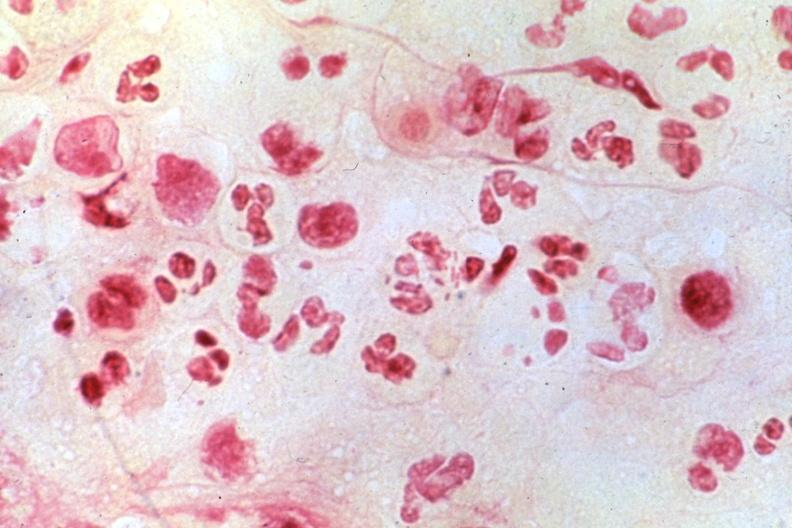what is present?
Answer the question using a single word or phrase. Penis 